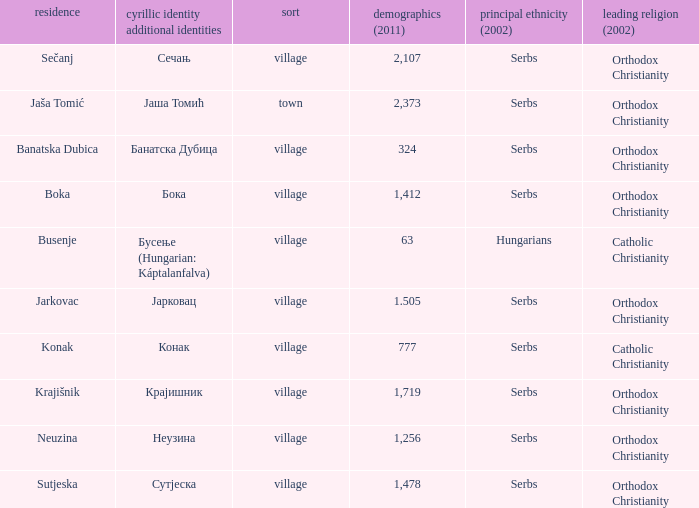What kind of type is  бока? Village. 